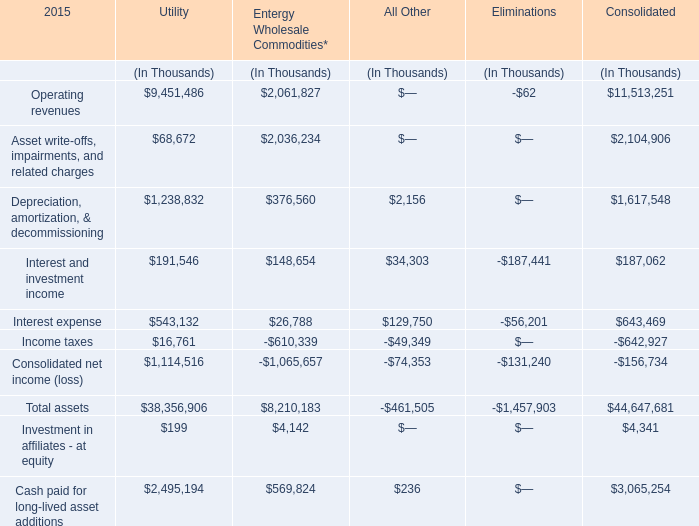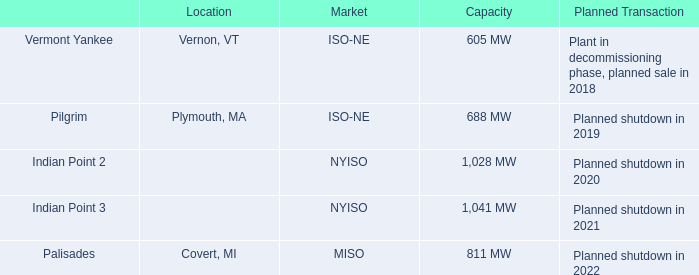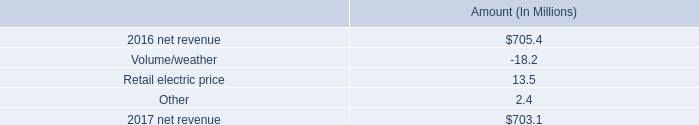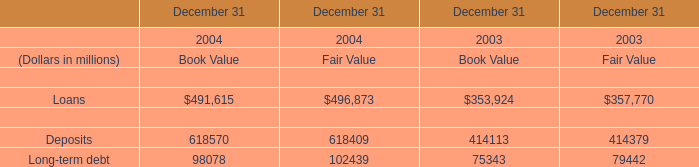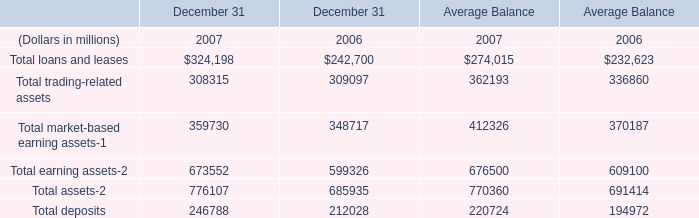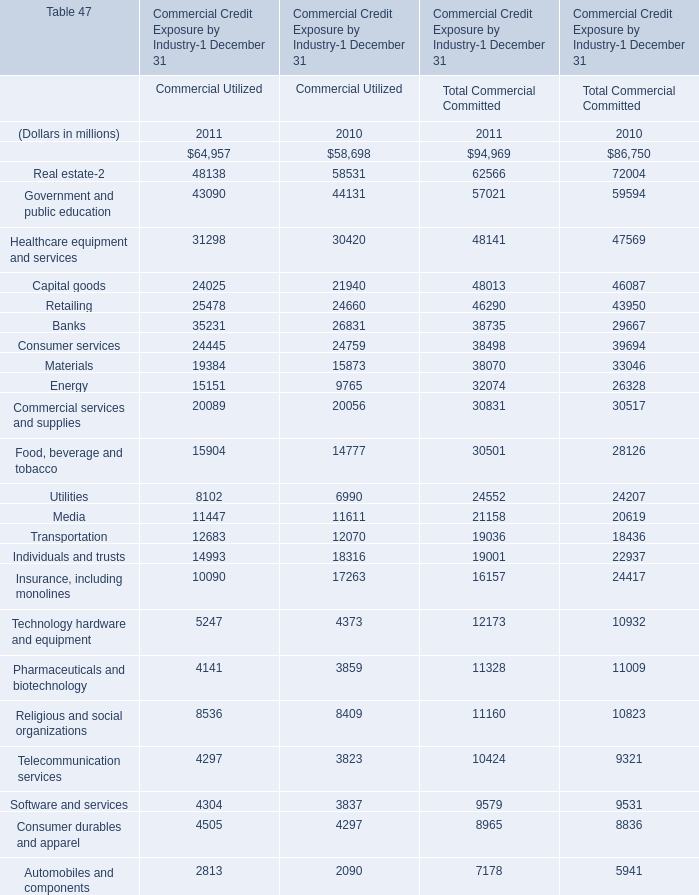What was the total amount of the Asset write-offs, impairments, and related charges in the year where Investment in affiliates - at equity is greater than 100? (in Thousand) 
Computations: ((68672 + 2104906) + 2036234)
Answer: 4209812.0. 